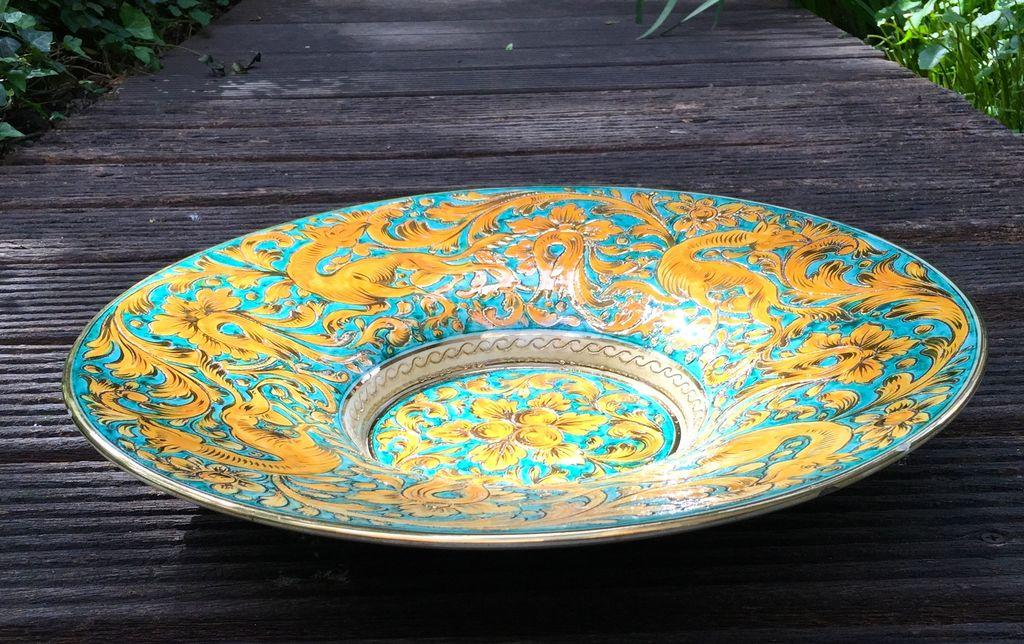What is on the ceramic plate in the image? The ceramic plate has a design in the image. Where is the ceramic plate located? The plate is placed on a wooden pathway. What type of vegetation is visible in the image? There are plants with leaves visible in the image. What type of wool is being used to create the design on the ceramic plate? There is no wool present in the image, and the design on the ceramic plate is not made of wool. 